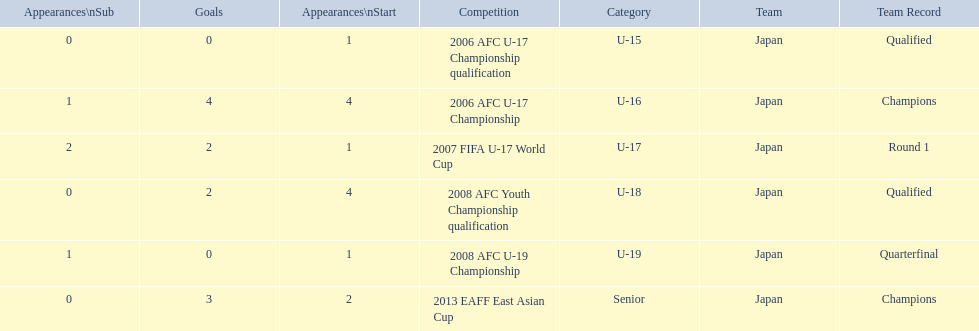What are all of the competitions? 2006 AFC U-17 Championship qualification, 2006 AFC U-17 Championship, 2007 FIFA U-17 World Cup, 2008 AFC Youth Championship qualification, 2008 AFC U-19 Championship, 2013 EAFF East Asian Cup. How many starting appearances were there? 1, 4, 1, 4, 1, 2. What about just during 2013 eaff east asian cup and 2007 fifa u-17 world cup? 1, 2. Which of those had more starting appearances? 2013 EAFF East Asian Cup. 